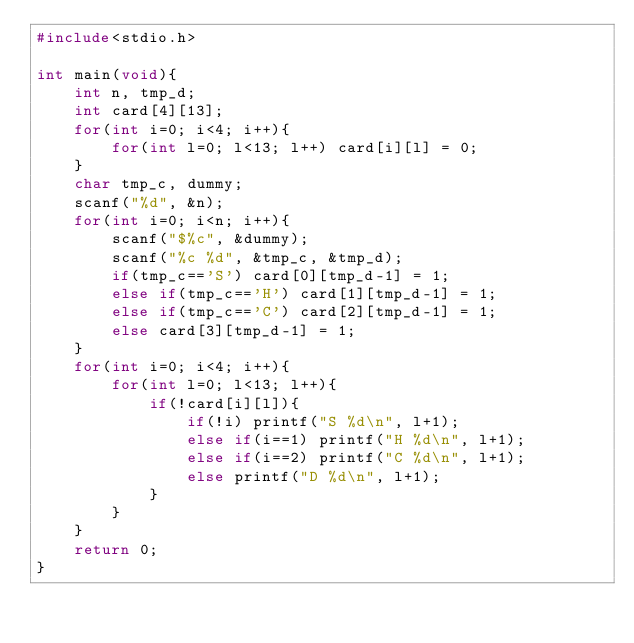<code> <loc_0><loc_0><loc_500><loc_500><_C_>#include<stdio.h>

int main(void){
    int n, tmp_d;
    int card[4][13];
    for(int i=0; i<4; i++){
        for(int l=0; l<13; l++) card[i][l] = 0;
    }
    char tmp_c, dummy;
    scanf("%d", &n);
    for(int i=0; i<n; i++){
        scanf("$%c", &dummy);
        scanf("%c %d", &tmp_c, &tmp_d);
        if(tmp_c=='S') card[0][tmp_d-1] = 1;
        else if(tmp_c=='H') card[1][tmp_d-1] = 1;
        else if(tmp_c=='C') card[2][tmp_d-1] = 1;
        else card[3][tmp_d-1] = 1;
    }
    for(int i=0; i<4; i++){
        for(int l=0; l<13; l++){
            if(!card[i][l]){
                if(!i) printf("S %d\n", l+1);
                else if(i==1) printf("H %d\n", l+1);
                else if(i==2) printf("C %d\n", l+1);
                else printf("D %d\n", l+1);
            }
        }
    }
    return 0;
}
</code> 